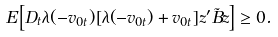<formula> <loc_0><loc_0><loc_500><loc_500>E \left [ D _ { t } \lambda ( - v _ { 0 t } ) [ \lambda ( - v _ { 0 t } ) + v _ { 0 t } ] z ^ { \prime } \tilde { B } z \right ] \geq 0 .</formula> 